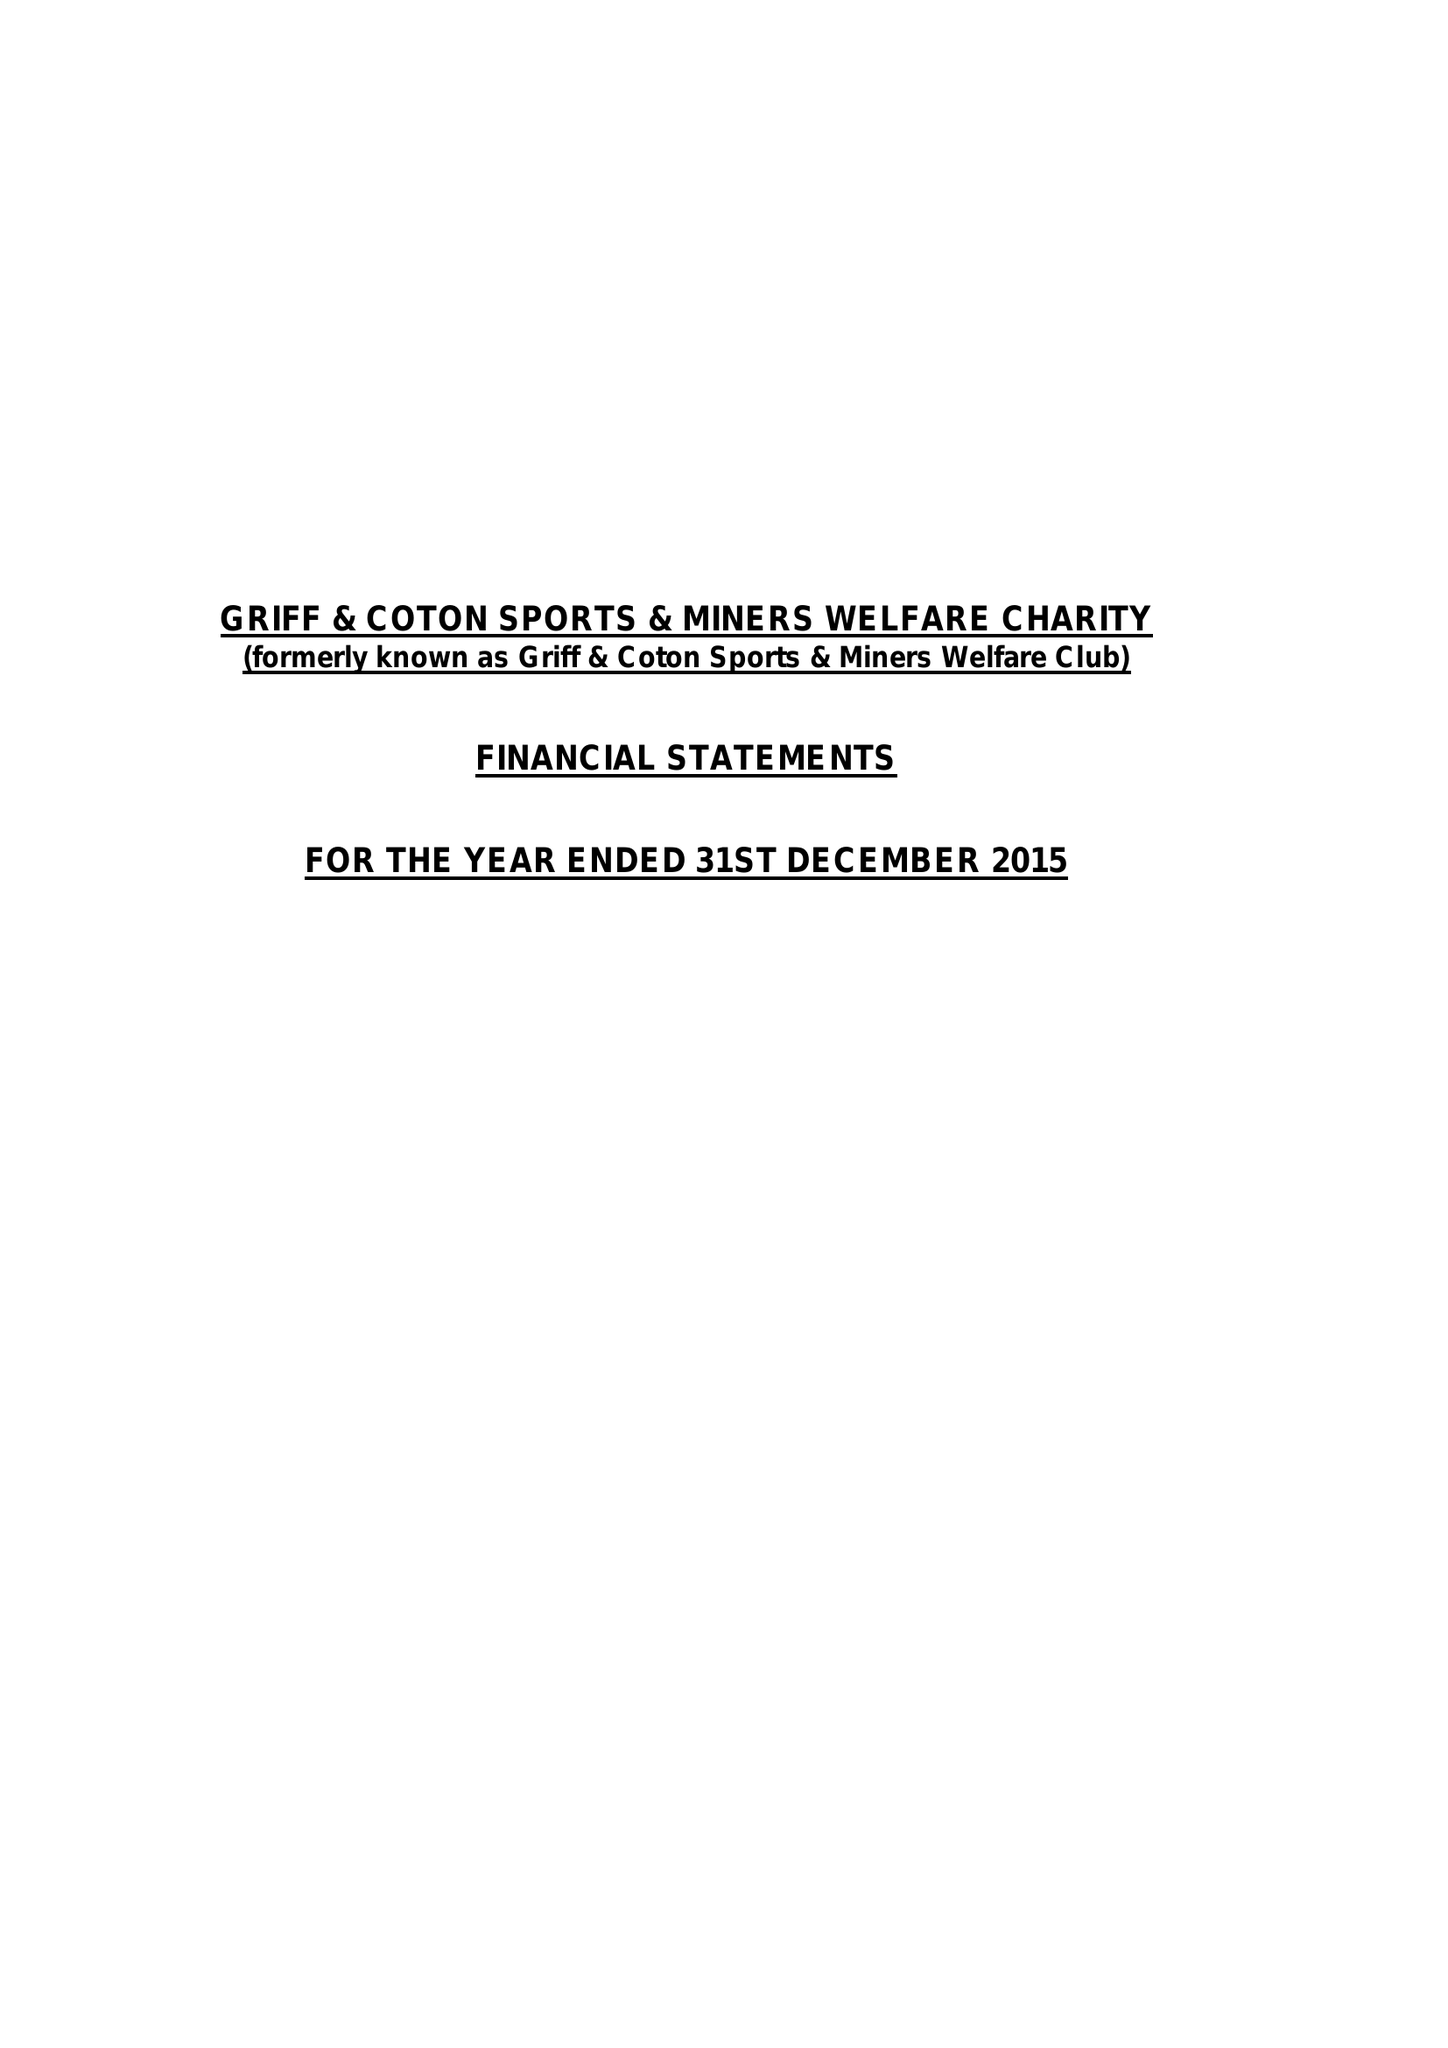What is the value for the address__post_town?
Answer the question using a single word or phrase. NUNEATON 